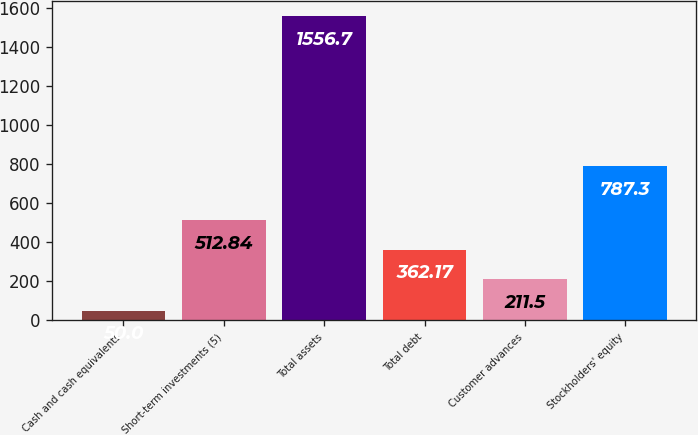Convert chart to OTSL. <chart><loc_0><loc_0><loc_500><loc_500><bar_chart><fcel>Cash and cash equivalents<fcel>Short-term investments (5)<fcel>Total assets<fcel>Total debt<fcel>Customer advances<fcel>Stockholders' equity<nl><fcel>50<fcel>512.84<fcel>1556.7<fcel>362.17<fcel>211.5<fcel>787.3<nl></chart> 